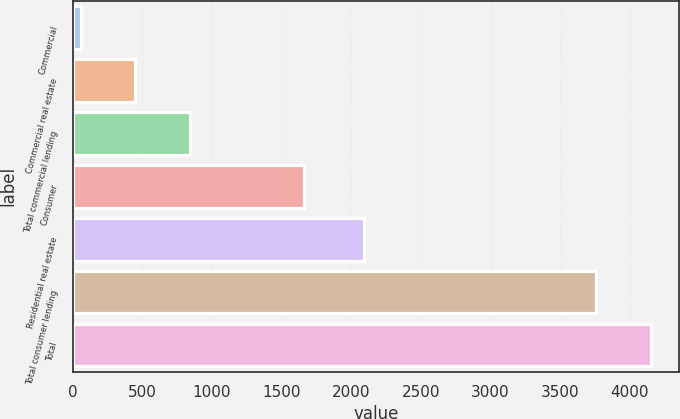Convert chart to OTSL. <chart><loc_0><loc_0><loc_500><loc_500><bar_chart><fcel>Commercial<fcel>Commercial real estate<fcel>Total commercial lending<fcel>Consumer<fcel>Residential real estate<fcel>Total consumer lending<fcel>Total<nl><fcel>57<fcel>449.9<fcel>842.8<fcel>1661<fcel>2094<fcel>3755<fcel>4147.9<nl></chart> 